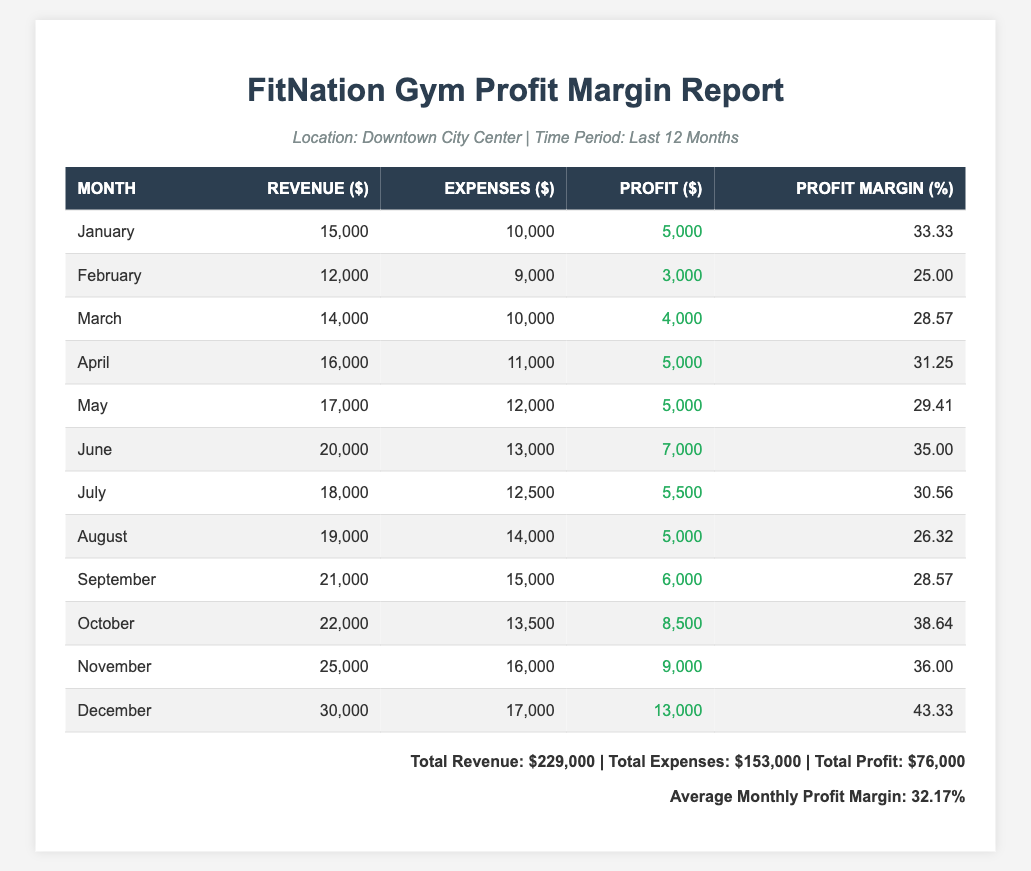What was the profit for December? According to the table, the profit for December is listed as $13,000.
Answer: $13,000 What is the total revenue over the last 12 months? To find the total revenue, add all the monthly revenues: 15,000 + 12,000 + 14,000 + 16,000 + 17,000 + 20,000 + 18,000 + 19,000 + 21,000 + 22,000 + 25,000 + 30,000 = 229,000.
Answer: $229,000 Which month had the highest profit margin? The highest profit margin is in December with 43.33%.
Answer: 43.33% Did the gym make a profit every month? Yes, the profit for each month shown in the table is positive, indicating that the gym made a profit every month.
Answer: Yes What is the average profit margin over the year? To find the average profit margin, sum all monthly profit margins and divide by 12. Total profit margin = 33.33 + 25.00 + 28.57 + 31.25 + 29.41 + 35.00 + 30.56 + 26.32 + 28.57 + 38.64 + 36.00 + 43.33 = 386.29, then divide by 12: 386.29 / 12 = approximately 32.17%.
Answer: 32.17% In which month did the gym have the lowest profit? The lowest profit was in February, where the profit is $3,000.
Answer: $3,000 What was the increase in profit from September to October? The profit in September is $6,000 and in October it is $8,500. The increase is calculated as $8,500 - $6,000 = $2,500.
Answer: $2,500 Which month had the highest expenses? The month with the highest expenses is November, with expenses totaling $16,000.
Answer: $16,000 What is the difference between the highest and lowest profit margins? The highest profit margin is in December at 43.33%, and the lowest is in February at 25.00%. The difference is 43.33% - 25.00% = 18.33%.
Answer: 18.33% Was the profit margin for June higher than that for August? In June, the profit margin is 35.00%, and in August, it is 26.32%. Since 35.00% is greater than 26.32%, June's profit margin was indeed higher.
Answer: Yes How much total profit did the gym make over the entire year? To find the total profit, add all monthly profits together: 5,000 + 3,000 + 4,000 + 5,000 + 5,000 + 7,000 + 5,500 + 5,000 + 6,000 + 8,500 + 9,000 + 13,000 = 76,000.
Answer: $76,000 